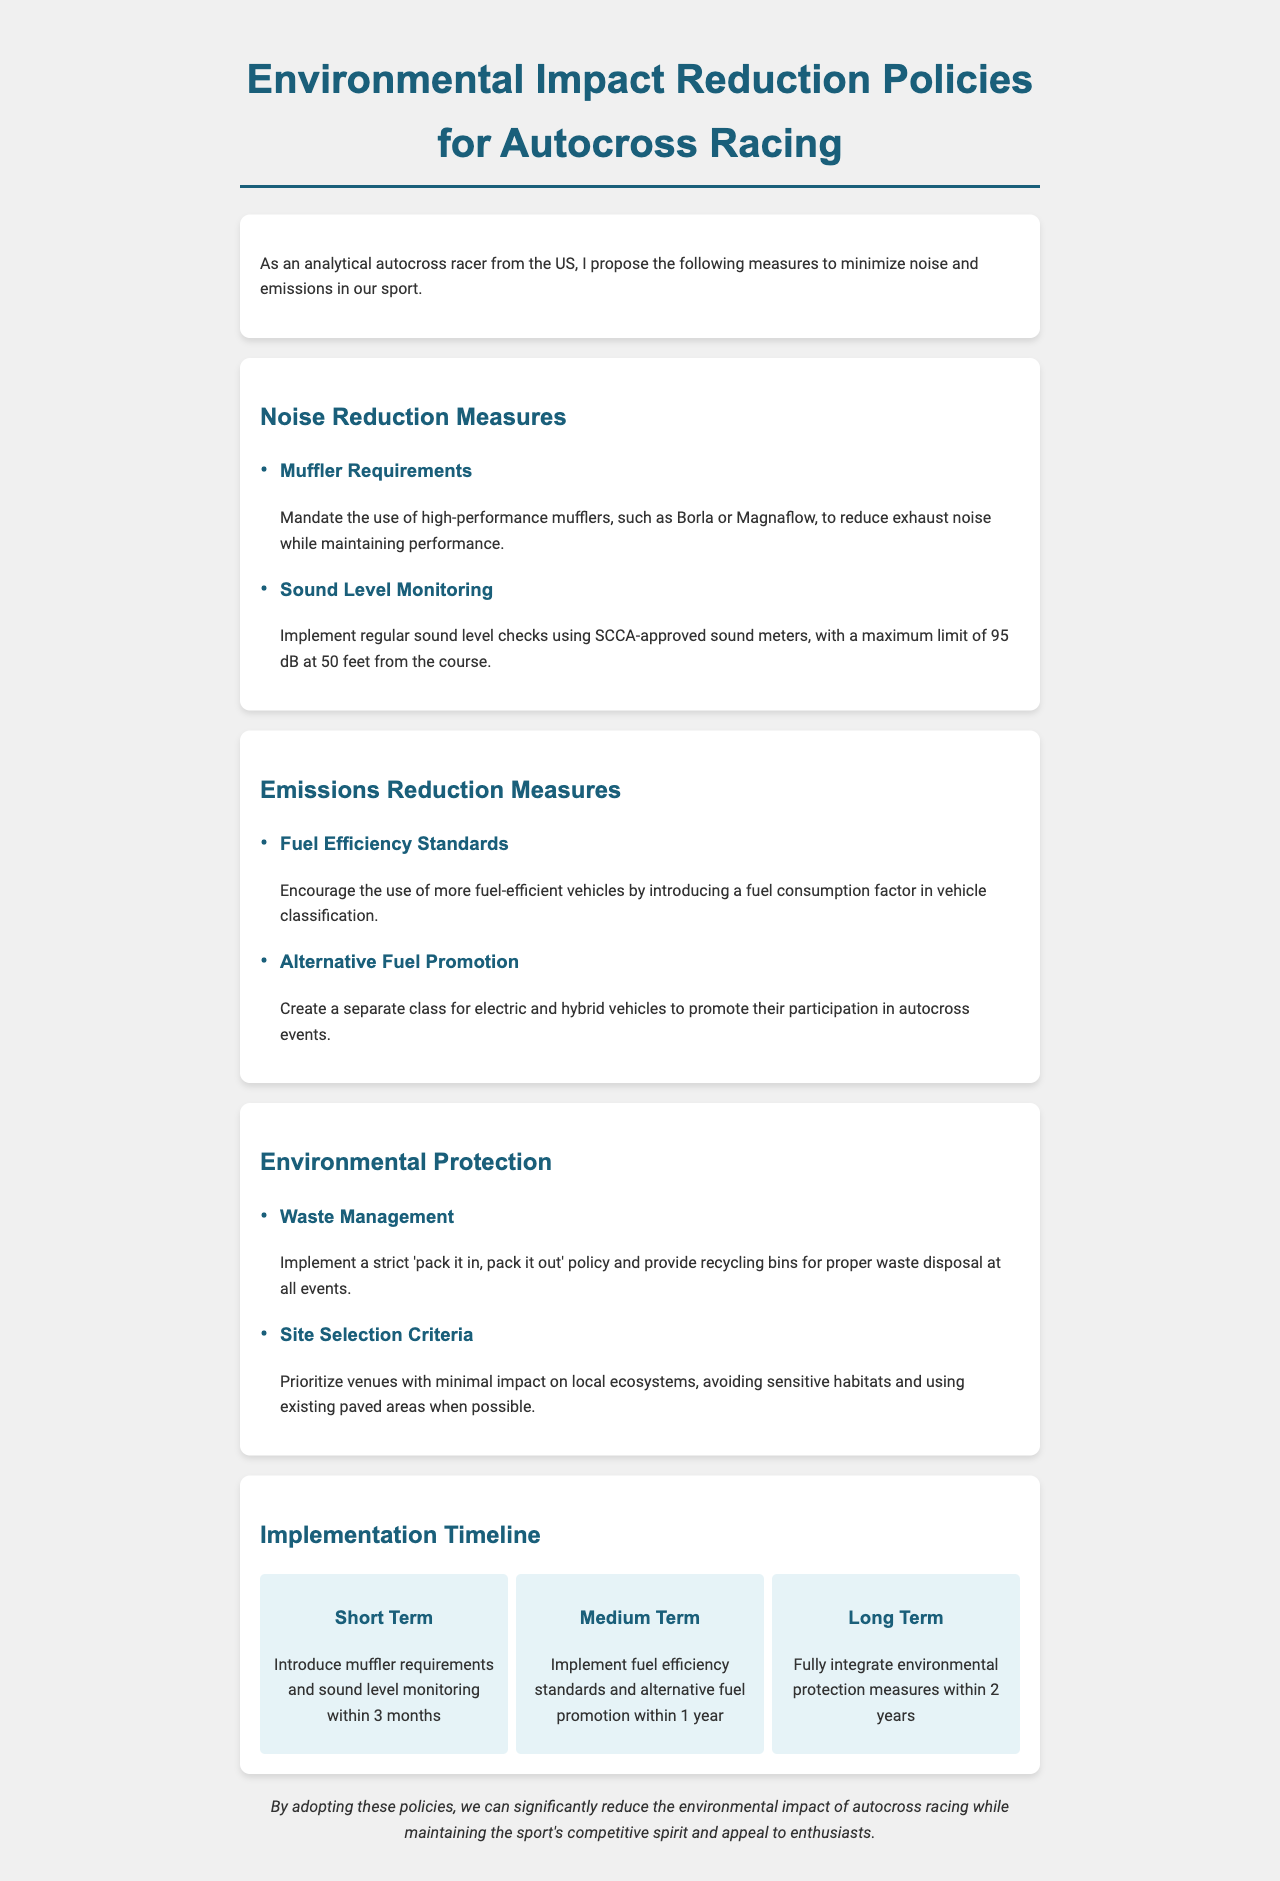what is the maximum sound level limit? The document states that the maximum sound level limit is 95 dB at 50 feet from the course.
Answer: 95 dB what is one example of a muffler recommended? The document mentions Borla or Magnaflow as examples of high-performance mufflers.
Answer: Borla how long is the short-term implementation period? The document specifies that the short-term implementation period is within 3 months.
Answer: 3 months what is one measure to manage waste at events? The document states to implement a strict 'pack it in, pack it out' policy.
Answer: 'pack it in, pack it out' what vehicle types are promoted for participation? The document mentions creating a separate class for electric and hybrid vehicles.
Answer: electric and hybrid vehicles what is the term for monitoring sound levels? The document refers to this as sound level monitoring using SCCA-approved sound meters.
Answer: sound level monitoring which section contains guidelines for site selection? The document has guidelines for site selection under the Environmental Protection section.
Answer: Environmental Protection what is the timeline for fully integrating environmental protection measures? The document indicates that this is to be done within 2 years.
Answer: 2 years what is a proposed benefit of adopting these policies? The document states that it can significantly reduce the environmental impact of autocross racing.
Answer: reduce the environmental impact 